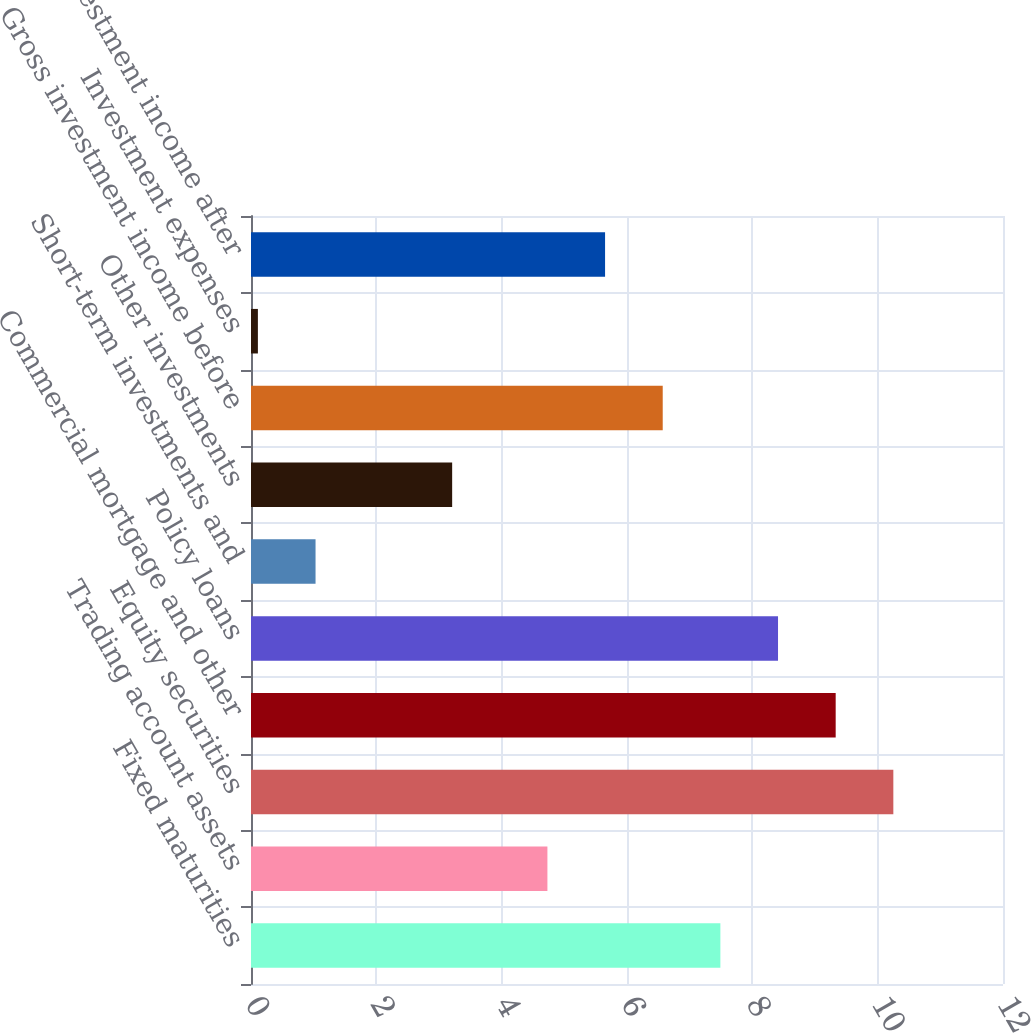Convert chart. <chart><loc_0><loc_0><loc_500><loc_500><bar_chart><fcel>Fixed maturities<fcel>Trading account assets<fcel>Equity securities<fcel>Commercial mortgage and other<fcel>Policy loans<fcel>Short-term investments and<fcel>Other investments<fcel>Gross investment income before<fcel>Investment expenses<fcel>Investment income after<nl><fcel>7.49<fcel>4.73<fcel>10.25<fcel>9.33<fcel>8.41<fcel>1.03<fcel>3.21<fcel>6.57<fcel>0.11<fcel>5.65<nl></chart> 